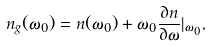<formula> <loc_0><loc_0><loc_500><loc_500>n _ { g } ( \omega _ { 0 } ) = n ( \omega _ { 0 } ) + \omega _ { 0 } \frac { \partial n } { \partial \omega } | _ { \omega _ { 0 } } ,</formula> 